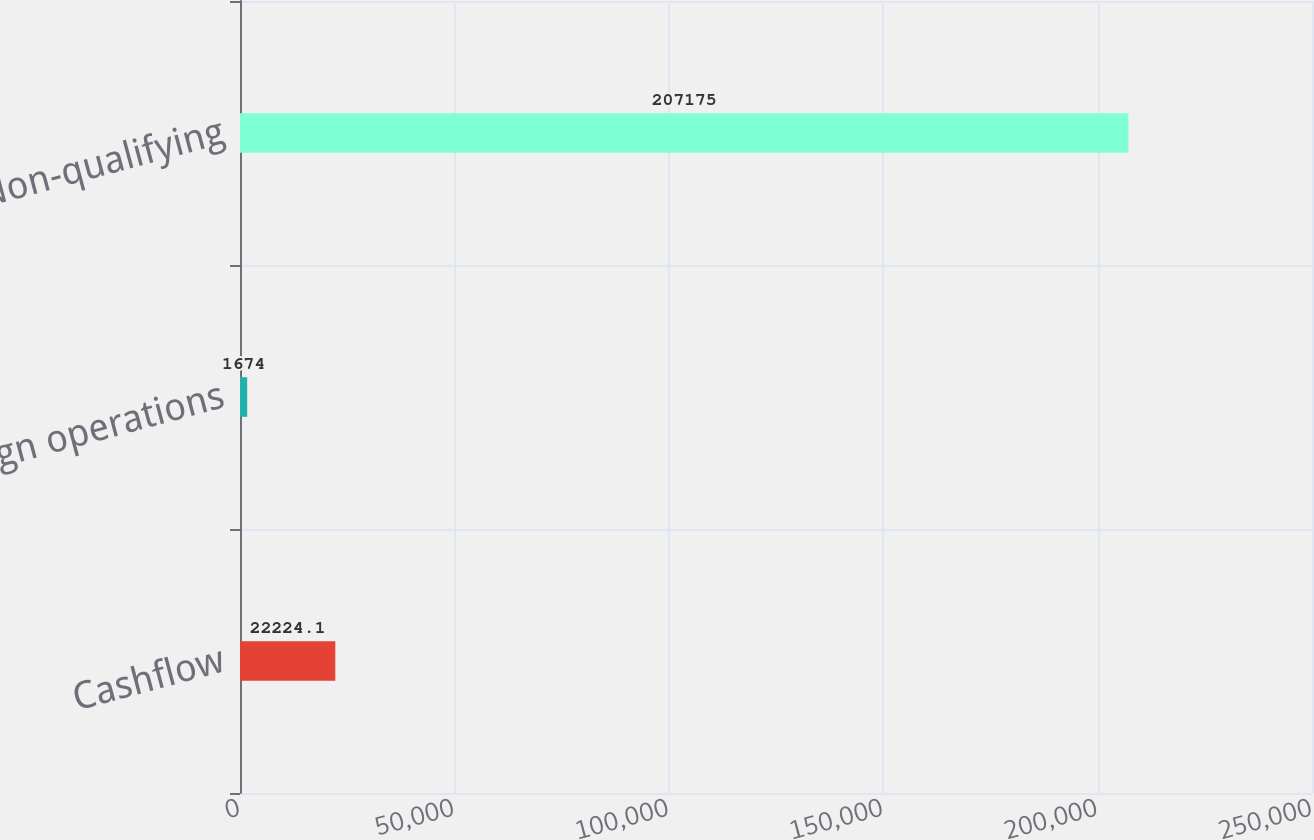Convert chart to OTSL. <chart><loc_0><loc_0><loc_500><loc_500><bar_chart><fcel>Cashflow<fcel>Foreign operations<fcel>Non-qualifying<nl><fcel>22224.1<fcel>1674<fcel>207175<nl></chart> 